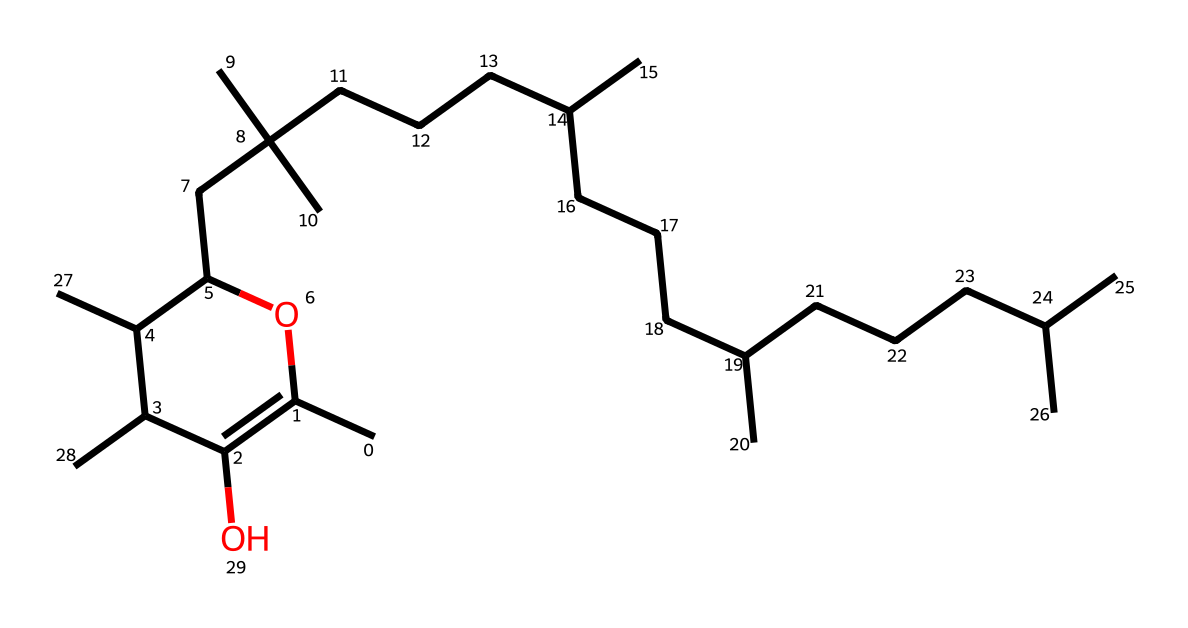What is the molecular formula of the vitamin represented? To find the molecular formula, we can analyze the SMILES representation for the number of carbon (C), hydrogen (H), and oxygen (O) atoms. Counting from the structure, there are 55 carbon atoms, 94 hydrogen atoms, and 2 oxygen atoms, leading to the formula C55H94O2.
Answer: C55H94O2 How many rings are present in this vitamin structure? By examining the SMILES structure, a cyclic component is indicated by the "C1" and "C(O1)" connections, showing that there is one ring formed in the structure.
Answer: 1 What type of bonding is primarily present in this compound? The structure consists mainly of single carbon-to-carbon and carbon-to-hydrogen bonds, characterized by "C" connections and the absence of double or triple bonds, making it primarily covalent.
Answer: covalent Which segment of the chemical structure indicates a presence of hydroxyl group? In the SMILES representation, "C(O" indicates the presence of a hydroxyl (-OH) group, characterized by the "O" bonded to a carbon atom, which distinguishes it as a structure with alcohol characteristics.
Answer: C(O) How does the side-chain length compare in natural versus synthetic vitamin E? In natural vitamin E, the side-chains tend to vary in length and branching due to diverse biosynthetic pathways, whereas synthetic forms often have more controlled chain lengths. Comparing the side-chain in this structure, there are multiple branched structures suggesting a more complex, natural variant.
Answer: complex What is the primary biological role of vitamin E as indicated by its structure? Vitamin E, represented by this structure, functions primarily as an antioxidant, which is indicated by its chemical properties allowing it to stabilize free radicals and protect cellular components from oxidative damage.
Answer: antioxidant 